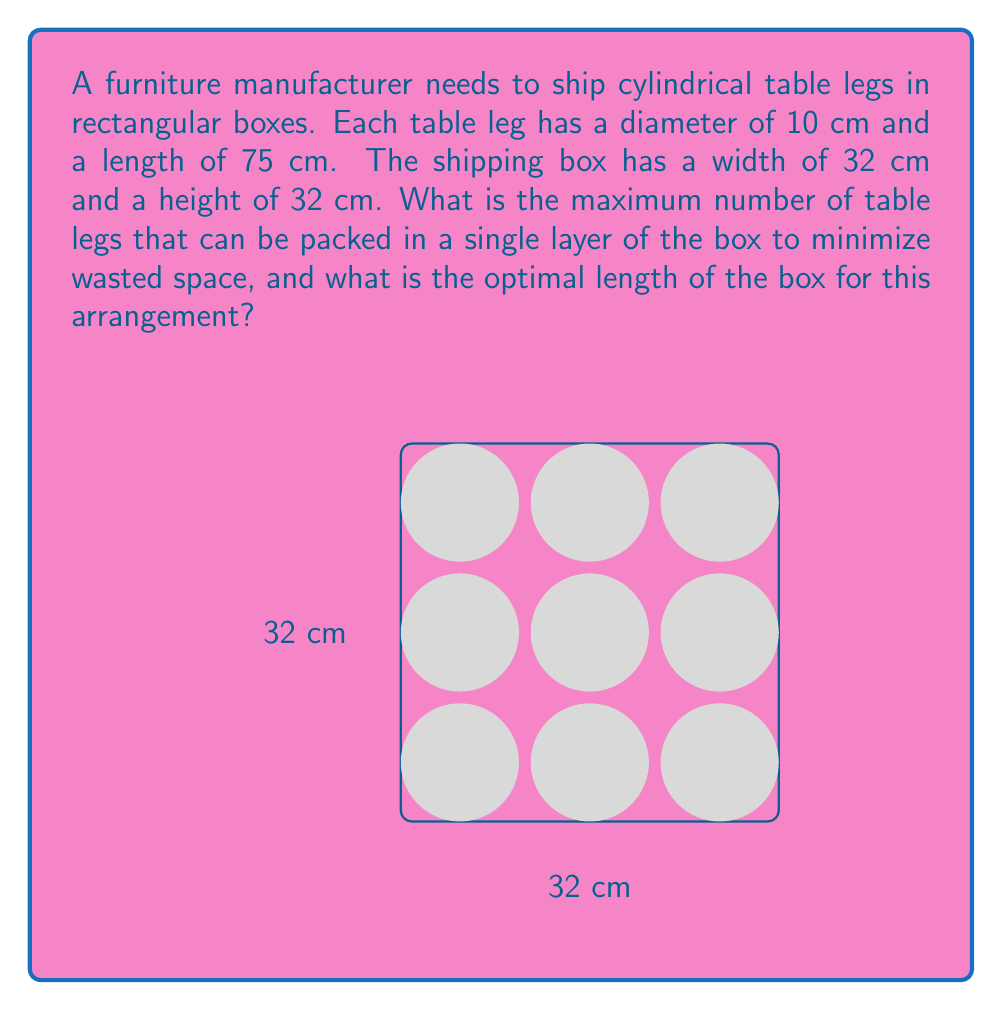Provide a solution to this math problem. To solve this problem, we need to follow these steps:

1) First, we need to determine the most efficient packing arrangement for circular objects in a rectangular space. The hexagonal packing arrangement is known to be the most efficient for circles.

2) In a hexagonal packing, the centers of the circles form equilateral triangles. The distance between the centers of adjacent circles is equal to the diameter of the circles.

3) For our case, the diameter is 10 cm. Let's calculate how many circles can fit along the width and height of the box:

   $$ \text{Number along width} = \lfloor \frac{32}{10} \rfloor = 3 $$
   $$ \text{Number along height} = \lfloor \frac{32}{10} \rfloor = 3 $$

4) In a hexagonal packing, alternate rows are offset. The total number of circles that can be packed is:

   $$ \text{Total circles} = 3 \times 3 = 9 $$

5) Now, to calculate the optimal length of the box, we need to consider the length of the table legs (75 cm) and add a small buffer for packaging material, say 1 cm on each end:

   $$ \text{Optimal length} = 75 + 2 = 77 \text{ cm} $$

6) Therefore, the optimal dimensions of the box are 32 cm × 32 cm × 77 cm, which can hold 9 table legs in a single layer.
Answer: 9 table legs; 77 cm long box 